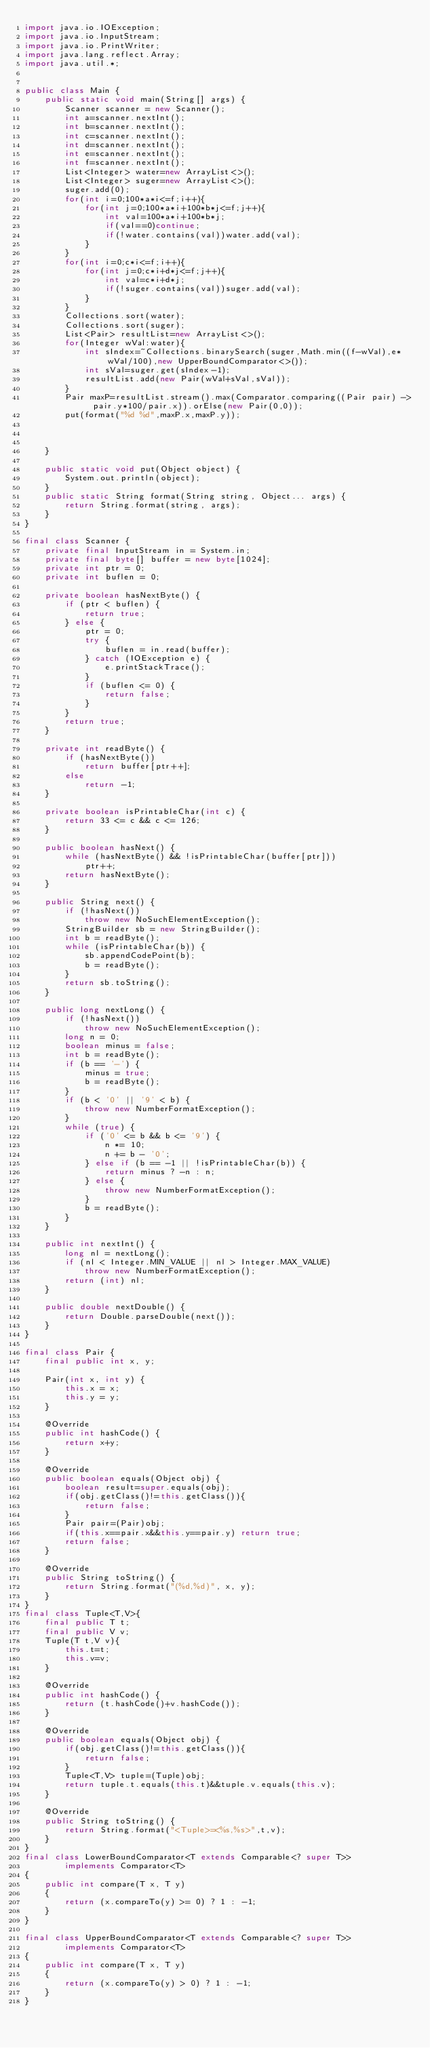<code> <loc_0><loc_0><loc_500><loc_500><_Java_>import java.io.IOException;
import java.io.InputStream;
import java.io.PrintWriter;
import java.lang.reflect.Array;
import java.util.*;


public class Main {
    public static void main(String[] args) {
        Scanner scanner = new Scanner();
        int a=scanner.nextInt();
        int b=scanner.nextInt();
        int c=scanner.nextInt();
        int d=scanner.nextInt();
        int e=scanner.nextInt();
        int f=scanner.nextInt();
        List<Integer> water=new ArrayList<>();
        List<Integer> suger=new ArrayList<>();
        suger.add(0);
        for(int i=0;100*a*i<=f;i++){
            for(int j=0;100*a*i+100*b*j<=f;j++){
                int val=100*a*i+100*b*j;
                if(val==0)continue;
                if(!water.contains(val))water.add(val);
            }
        }
        for(int i=0;c*i<=f;i++){
            for(int j=0;c*i+d*j<=f;j++){
                int val=c*i+d*j;
                if(!suger.contains(val))suger.add(val);
            }
        }
        Collections.sort(water);
        Collections.sort(suger);
        List<Pair> resultList=new ArrayList<>();
        for(Integer wVal:water){
            int sIndex=~Collections.binarySearch(suger,Math.min((f-wVal),e*wVal/100),new UpperBoundComparator<>());
            int sVal=suger.get(sIndex-1);
            resultList.add(new Pair(wVal+sVal,sVal));
        }
        Pair maxP=resultList.stream().max(Comparator.comparing((Pair pair) -> pair.y*100/pair.x)).orElse(new Pair(0,0));
        put(format("%d %d",maxP.x,maxP.y));



    }

    public static void put(Object object) {
        System.out.println(object);
    }
    public static String format(String string, Object... args) {
        return String.format(string, args);
    }
}

final class Scanner {
    private final InputStream in = System.in;
    private final byte[] buffer = new byte[1024];
    private int ptr = 0;
    private int buflen = 0;

    private boolean hasNextByte() {
        if (ptr < buflen) {
            return true;
        } else {
            ptr = 0;
            try {
                buflen = in.read(buffer);
            } catch (IOException e) {
                e.printStackTrace();
            }
            if (buflen <= 0) {
                return false;
            }
        }
        return true;
    }

    private int readByte() {
        if (hasNextByte())
            return buffer[ptr++];
        else
            return -1;
    }

    private boolean isPrintableChar(int c) {
        return 33 <= c && c <= 126;
    }

    public boolean hasNext() {
        while (hasNextByte() && !isPrintableChar(buffer[ptr]))
            ptr++;
        return hasNextByte();
    }

    public String next() {
        if (!hasNext())
            throw new NoSuchElementException();
        StringBuilder sb = new StringBuilder();
        int b = readByte();
        while (isPrintableChar(b)) {
            sb.appendCodePoint(b);
            b = readByte();
        }
        return sb.toString();
    }

    public long nextLong() {
        if (!hasNext())
            throw new NoSuchElementException();
        long n = 0;
        boolean minus = false;
        int b = readByte();
        if (b == '-') {
            minus = true;
            b = readByte();
        }
        if (b < '0' || '9' < b) {
            throw new NumberFormatException();
        }
        while (true) {
            if ('0' <= b && b <= '9') {
                n *= 10;
                n += b - '0';
            } else if (b == -1 || !isPrintableChar(b)) {
                return minus ? -n : n;
            } else {
                throw new NumberFormatException();
            }
            b = readByte();
        }
    }

    public int nextInt() {
        long nl = nextLong();
        if (nl < Integer.MIN_VALUE || nl > Integer.MAX_VALUE)
            throw new NumberFormatException();
        return (int) nl;
    }

    public double nextDouble() {
        return Double.parseDouble(next());
    }
}

final class Pair {
    final public int x, y;

    Pair(int x, int y) {
        this.x = x;
        this.y = y;
    }

    @Override
    public int hashCode() {
        return x+y;
    }

    @Override
    public boolean equals(Object obj) {
        boolean result=super.equals(obj);
        if(obj.getClass()!=this.getClass()){
            return false;
        }
        Pair pair=(Pair)obj;
        if(this.x==pair.x&&this.y==pair.y) return true;
        return false;
    }

    @Override
    public String toString() {
        return String.format("(%d,%d)", x, y);
    }
}
final class Tuple<T,V>{
    final public T t;
    final public V v;
    Tuple(T t,V v){
        this.t=t;
        this.v=v;
    }

    @Override
    public int hashCode() {
        return (t.hashCode()+v.hashCode());
    }

    @Override
    public boolean equals(Object obj) {
        if(obj.getClass()!=this.getClass()){
            return false;
        }
        Tuple<T,V> tuple=(Tuple)obj;
        return tuple.t.equals(this.t)&&tuple.v.equals(this.v);
    }

    @Override
    public String toString() {
        return String.format("<Tuple>=<%s,%s>",t,v);
    }
}
final class LowerBoundComparator<T extends Comparable<? super T>>
        implements Comparator<T>
{
    public int compare(T x, T y)
    {
        return (x.compareTo(y) >= 0) ? 1 : -1;
    }
}

final class UpperBoundComparator<T extends Comparable<? super T>>
        implements Comparator<T>
{
    public int compare(T x, T y)
    {
        return (x.compareTo(y) > 0) ? 1 : -1;
    }
}
</code> 